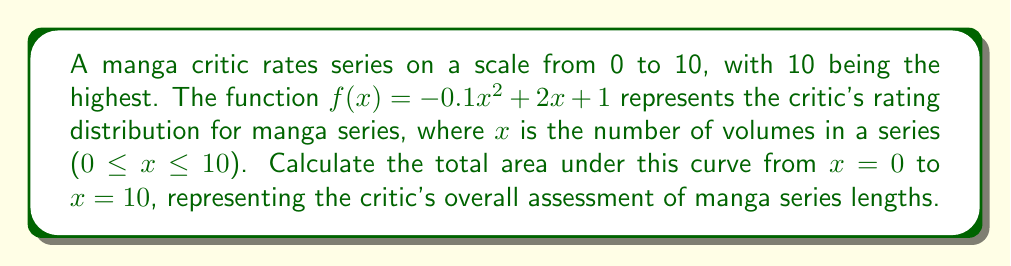What is the answer to this math problem? To find the area under the curve, we need to integrate the function $f(x)$ from 0 to 10. Let's follow these steps:

1) The function is $f(x) = -0.1x^2 + 2x + 1$

2) We need to find $\int_0^{10} f(x) dx$

3) Integrate each term:
   $$\int (-0.1x^2 + 2x + 1) dx = -\frac{1}{30}x^3 + x^2 + x + C$$

4) Now we need to evaluate this from 0 to 10:
   $$[-\frac{1}{30}x^3 + x^2 + x]_0^{10}$$

5) Substitute x = 10:
   $$-\frac{1}{30}(10^3) + (10^2) + 10 = -\frac{1000}{30} + 100 + 10 = -33.33 + 110 = 76.67$$

6) Substitute x = 0:
   $$-\frac{1}{30}(0^3) + (0^2) + 0 = 0$$

7) Subtract the result of step 6 from step 5:
   $$76.67 - 0 = 76.67$$

Therefore, the total area under the curve from x = 0 to x = 10 is 76.67.
Answer: 76.67 square units 